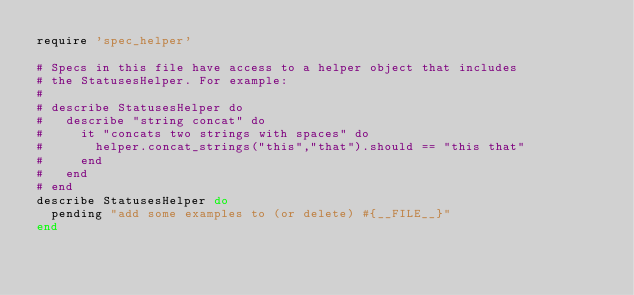Convert code to text. <code><loc_0><loc_0><loc_500><loc_500><_Ruby_>require 'spec_helper'

# Specs in this file have access to a helper object that includes
# the StatusesHelper. For example:
#
# describe StatusesHelper do
#   describe "string concat" do
#     it "concats two strings with spaces" do
#       helper.concat_strings("this","that").should == "this that"
#     end
#   end
# end
describe StatusesHelper do
  pending "add some examples to (or delete) #{__FILE__}"
end
</code> 